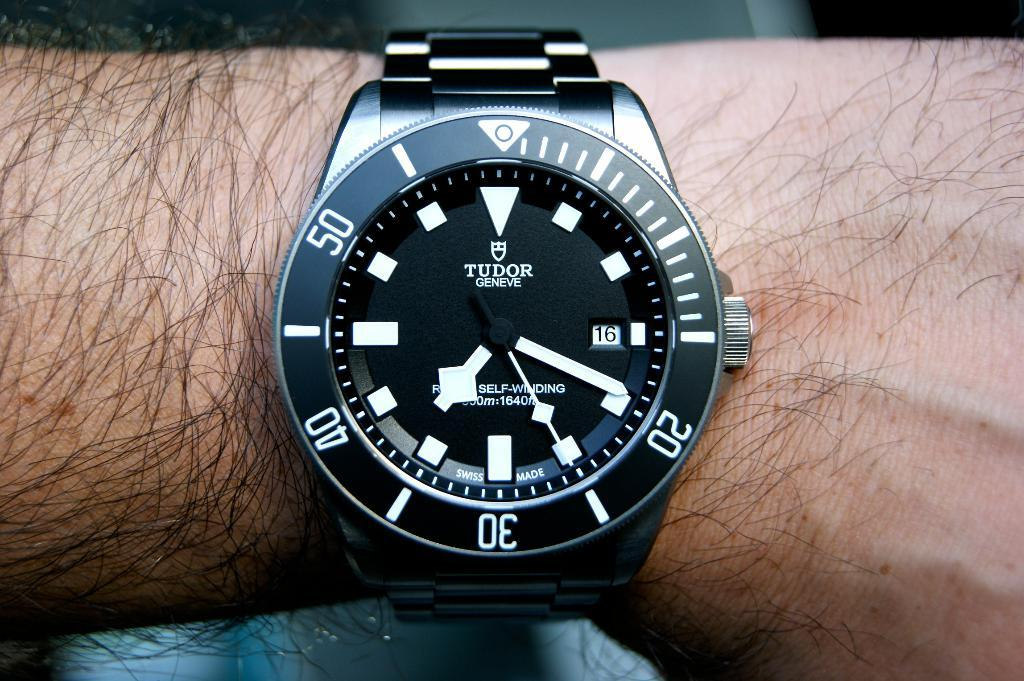<image>
Offer a succinct explanation of the picture presented. Person wearing a black and white wristwatch which says TUDOR on the top. 